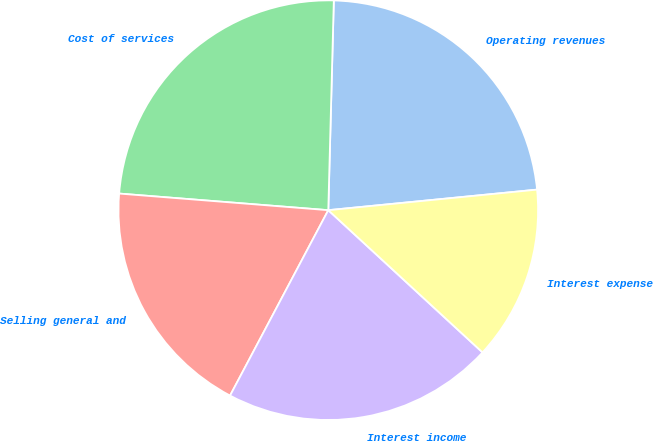Convert chart to OTSL. <chart><loc_0><loc_0><loc_500><loc_500><pie_chart><fcel>Operating revenues<fcel>Cost of services<fcel>Selling general and<fcel>Interest income<fcel>Interest expense<nl><fcel>23.02%<fcel>24.16%<fcel>18.51%<fcel>20.9%<fcel>13.42%<nl></chart> 